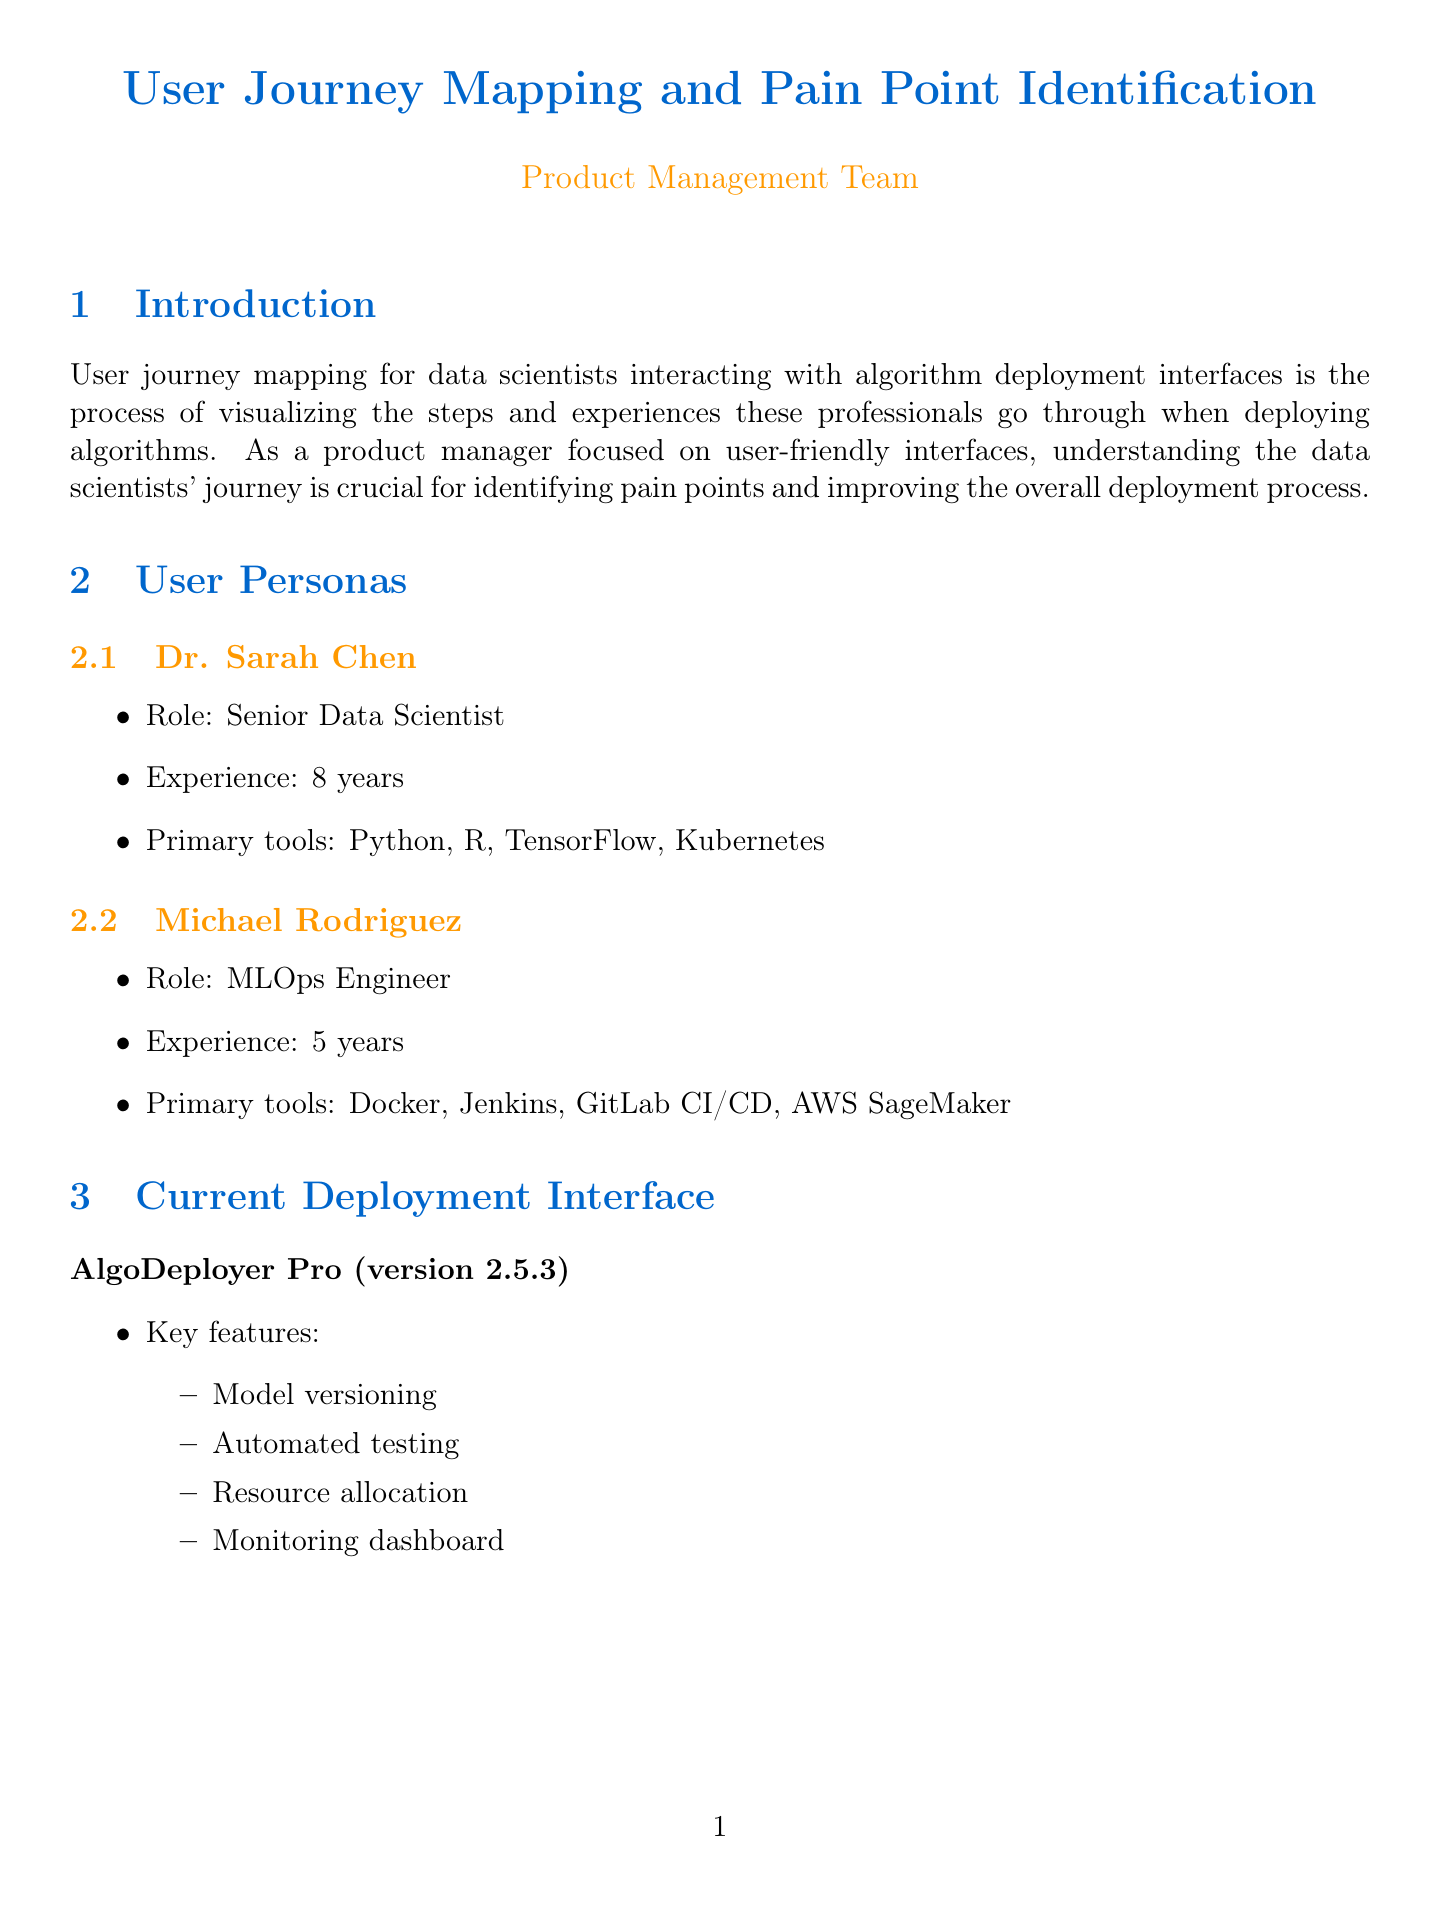What is the name of the current deployment interface? The current deployment interface is specifically named in the document, which is "AlgoDeployer Pro".
Answer: AlgoDeployer Pro Who is the MLOps Engineer persona? The persona section details individuals, and Michael Rodriguez is identified as the MLOps Engineer.
Answer: Michael Rodriguez What is one identified pain point during the Preparation stage? The document lists a specific pain point in this stage, which is related to environment setup difficulties.
Answer: Difficulty in translating local environment setup to deployment environment What feature is appreciated by Michael Rodriguez? The user feedback section indicates that Michael Rodriguez appreciates specific features, particularly regarding automated testing.
Answer: Automated testing What is the expected impact of implementing a modular dashboard? The document outlines expected impacts of various improvements, including the effect of a modular dashboard on user satisfaction and navigation time.
Answer: Improved user satisfaction and reduced time spent navigating the interface Which stage has a high impact pain point related to unclear error messages? The impact assessment of pain points shows that the Deployment stage contains a significant issue regarding unclear error messages.
Answer: Deployment What is one of the recommended improvements for error handling? The recommendations section suggests a specific improvement in error handling, emphasizing an intelligent resolution system.
Answer: Create an intelligent error resolution system How many years of experience does Dr. Sarah Chen have? The user persona details provide specific experience years for each persona, indicating that Dr. Sarah Chen has 8 years of experience.
Answer: 8 years 